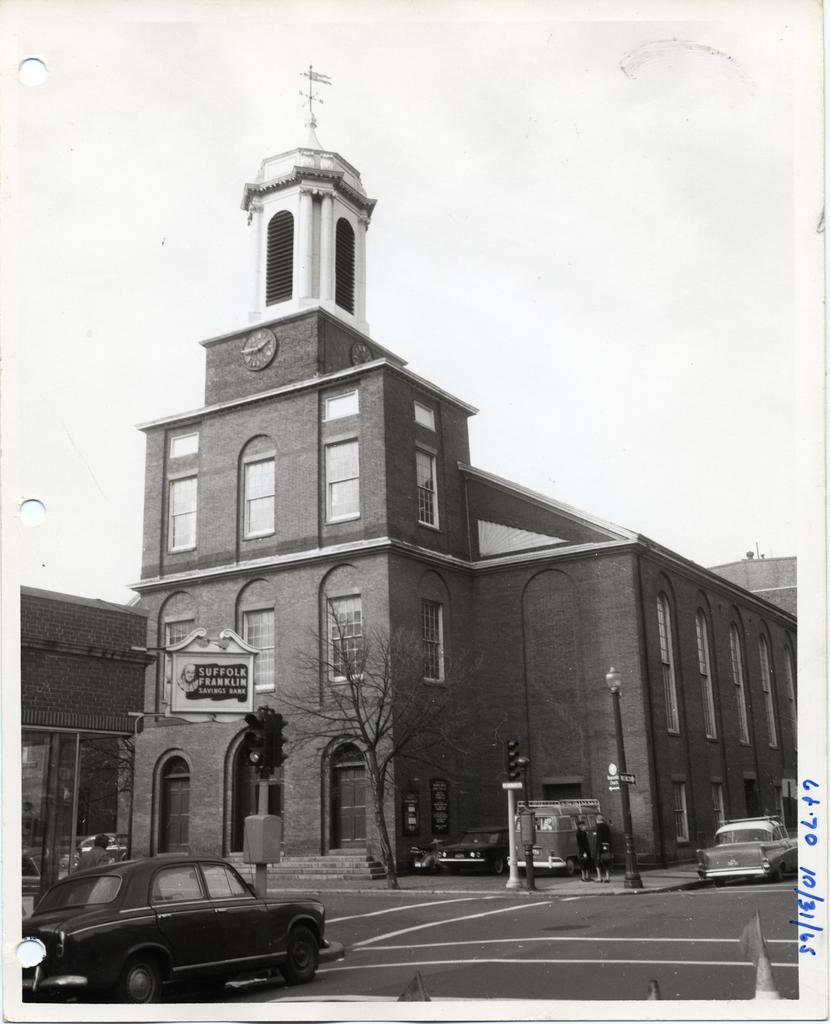What can be seen in the image? There are vehicles and people on the road in the image. What is present in the background of the image? There are traffic signals, poles, buildings, a tree, and the sky visible in the background of the image. What might be used to control traffic in the image? Traffic signals in the background of the image might be used to control traffic. What type of cabbage is being used as a ball in the image? There is no cabbage or ball present in the image. 